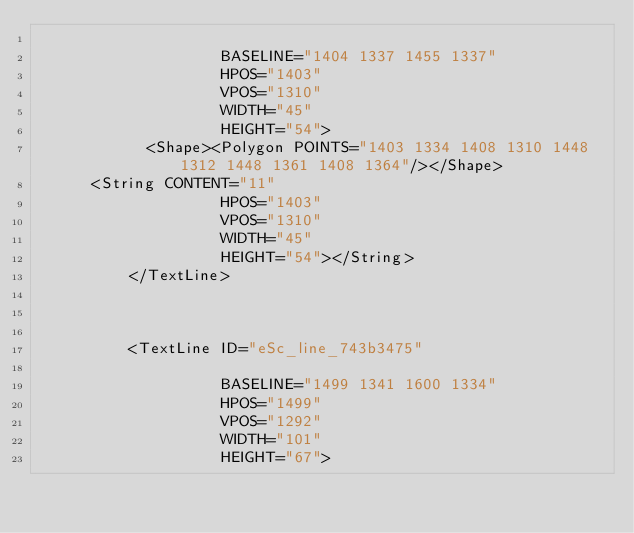<code> <loc_0><loc_0><loc_500><loc_500><_XML_>                    
                    BASELINE="1404 1337 1455 1337" 
                    HPOS="1403"
                    VPOS="1310"
                    WIDTH="45"
                    HEIGHT="54">
            <Shape><Polygon POINTS="1403 1334 1408 1310 1448 1312 1448 1361 1408 1364"/></Shape>
	    <String CONTENT="11"
                    HPOS="1403"
                    VPOS="1310"
                    WIDTH="45"
                    HEIGHT="54"></String>
          </TextLine>

          
          
          <TextLine ID="eSc_line_743b3475"
                    
                    BASELINE="1499 1341 1600 1334" 
                    HPOS="1499"
                    VPOS="1292"
                    WIDTH="101"
                    HEIGHT="67"></code> 